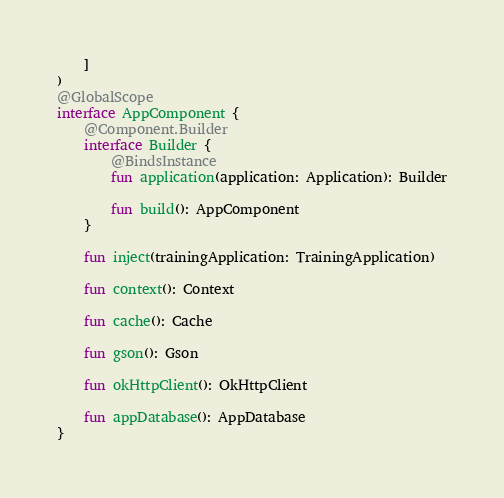Convert code to text. <code><loc_0><loc_0><loc_500><loc_500><_Kotlin_>    ]
)
@GlobalScope
interface AppComponent {
    @Component.Builder
    interface Builder {
        @BindsInstance
        fun application(application: Application): Builder

        fun build(): AppComponent
    }

    fun inject(trainingApplication: TrainingApplication)

    fun context(): Context

    fun cache(): Cache

    fun gson(): Gson

    fun okHttpClient(): OkHttpClient

    fun appDatabase(): AppDatabase
}</code> 